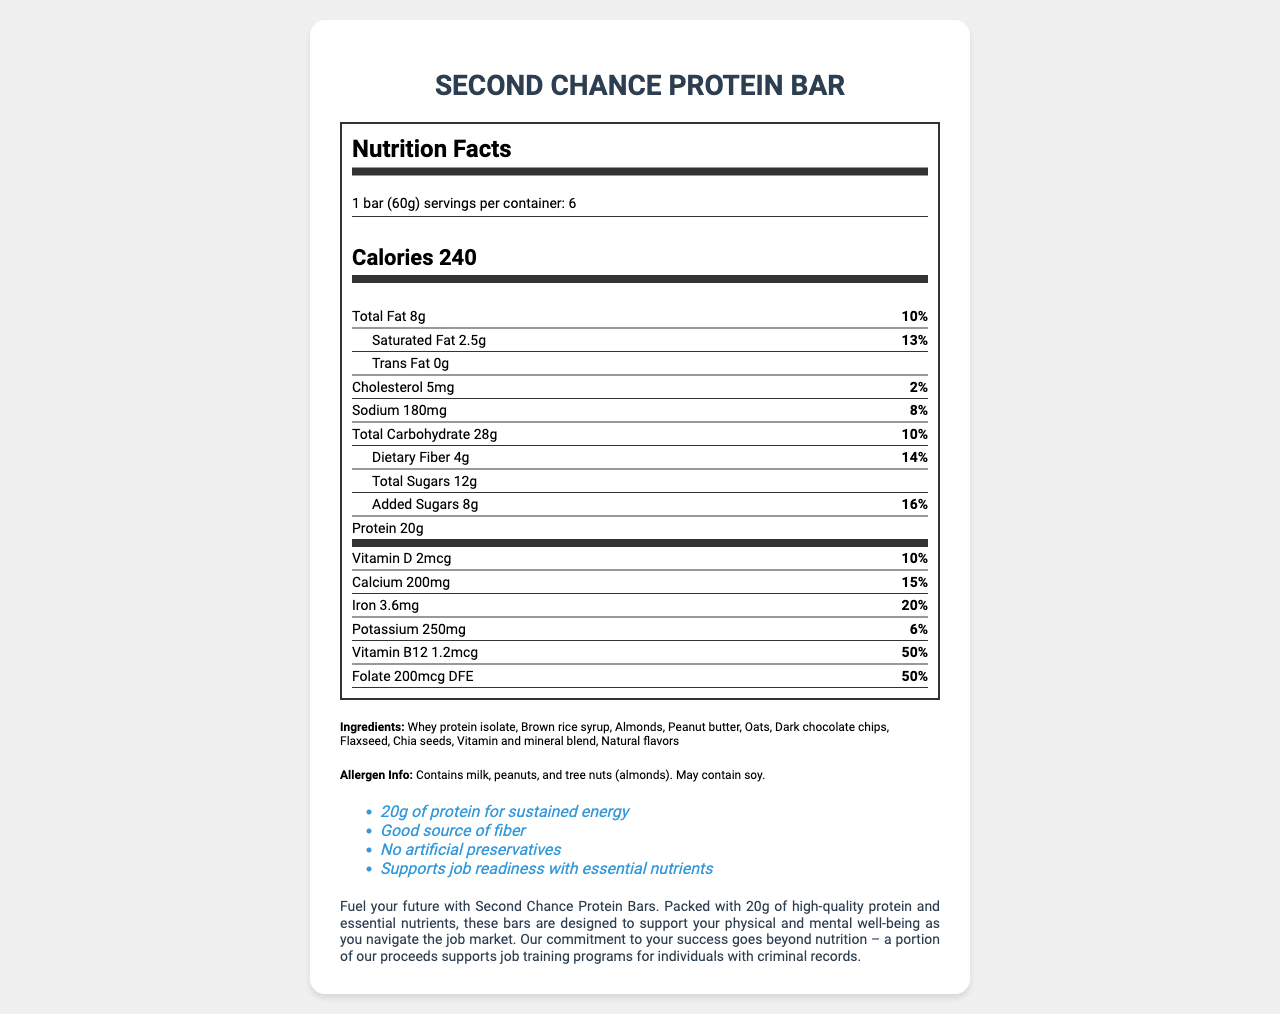what is the serving size of the Second Chance Protein Bar? The serving size is provided in the document as "1 bar (60g)".
Answer: 1 bar (60g) how many calories are in one serving of the Second Chance Protein Bar? The calorie content is stated as "Calories 240" in the document.
Answer: 240 which ingredient is listed first in the ingredients list? The first ingredient listed in the sequence is "Whey protein isolate".
Answer: Whey protein isolate what percentage of the daily value for fiber does one serving provide? The daily value for dietary fiber is provided as "14%" in the document.
Answer: 14% how much protein is in one serving of the Second Chance Protein Bar? The protein content is explicitly listed as "Protein 20g".
Answer: 20g how many servings are there per container? The document mentions that there are "6 servings per container".
Answer: 6 which vitamin covers 50% of the daily value? Both Vitamin B12 and Folate have a daily value of 50%.
Answer: Vitamin B12 and Folate which nutrient has the highest daily value percentage in one serving? A. Calcium B. Iron C. Folate D. Potassium Folate has a daily value percentage of 50%, the highest among the listed nutrients.
Answer: C. Folate how much saturated fat is in one serving? A. 1g B. 2.5g C. 4g D. 3g The document states "Saturated Fat 2.5g".
Answer: B. 2.5g is there any trans fat in the Second Chance Protein Bar? The document specifies that the trans fat content is "0g".
Answer: No does the product contain any artificial preservatives? It claims "No artificial preservatives" in the document.
Answer: No how should you describe the marketing text of the Second Chance Protein Bar? The marketing text highlights both nutritional benefits and social commitments.
Answer: The marketing text explains that the bar is designed to support physical and mental well-being for job seekers with criminal records and that proceeds support job training programs. how does the product support job readiness? The marketing text states that the bar supports job readiness with essential nutrients and that a portion of the proceeds supports job training programs.
Answer: By providing essential nutrients and supporting job training programs for individuals with criminal records what is the sodium content in one serving? The document lists "Sodium 180mg".
Answer: 180mg how much iron does one serving provide? The document lists "Iron 3.6mg".
Answer: 3.6mg what is the amount of added sugars in one serving? The amount of added sugars is listed as "Added Sugars 8g".
Answer: 8g how would you summarize the entire document? This summary captures the main idea and essential details provided in the nutrition facts label and the marketing message of the product.
Answer: The document provides detailed nutrition information for the Second Chance Protein Bar, emphasizing its protein content and essential nutrients, aiming to support job-seeking individuals with criminal records through both nutrition and contributions to job training programs. It includes serving size, calorie content, nutrients, ingredients, allergen info, and marketing text. who manufactures the Second Chance Protein Bar? The document does not provide information about the manufacturer of the Second Chance Protein Bar.
Answer: Not enough information 